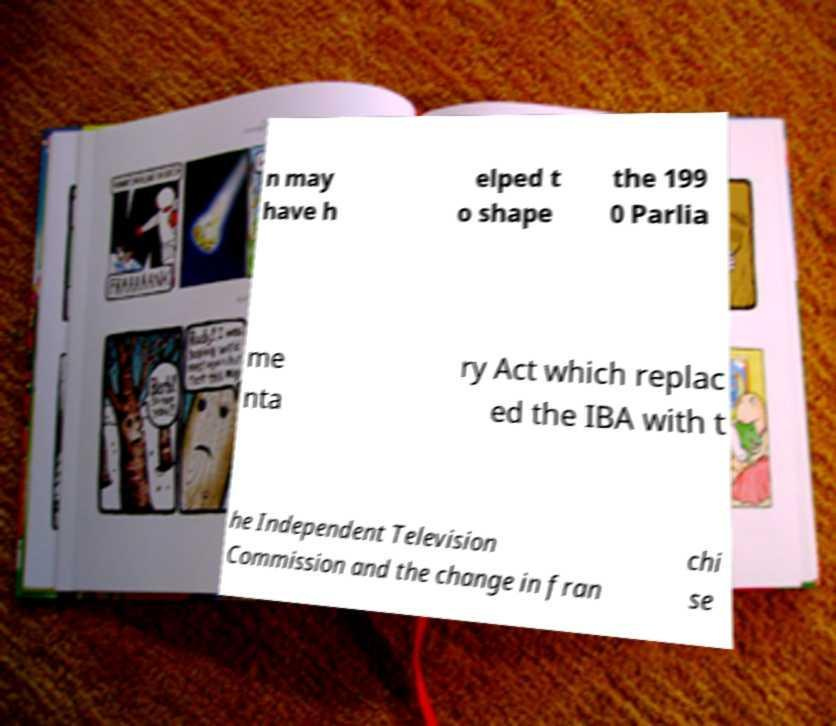Please read and relay the text visible in this image. What does it say? n may have h elped t o shape the 199 0 Parlia me nta ry Act which replac ed the IBA with t he Independent Television Commission and the change in fran chi se 